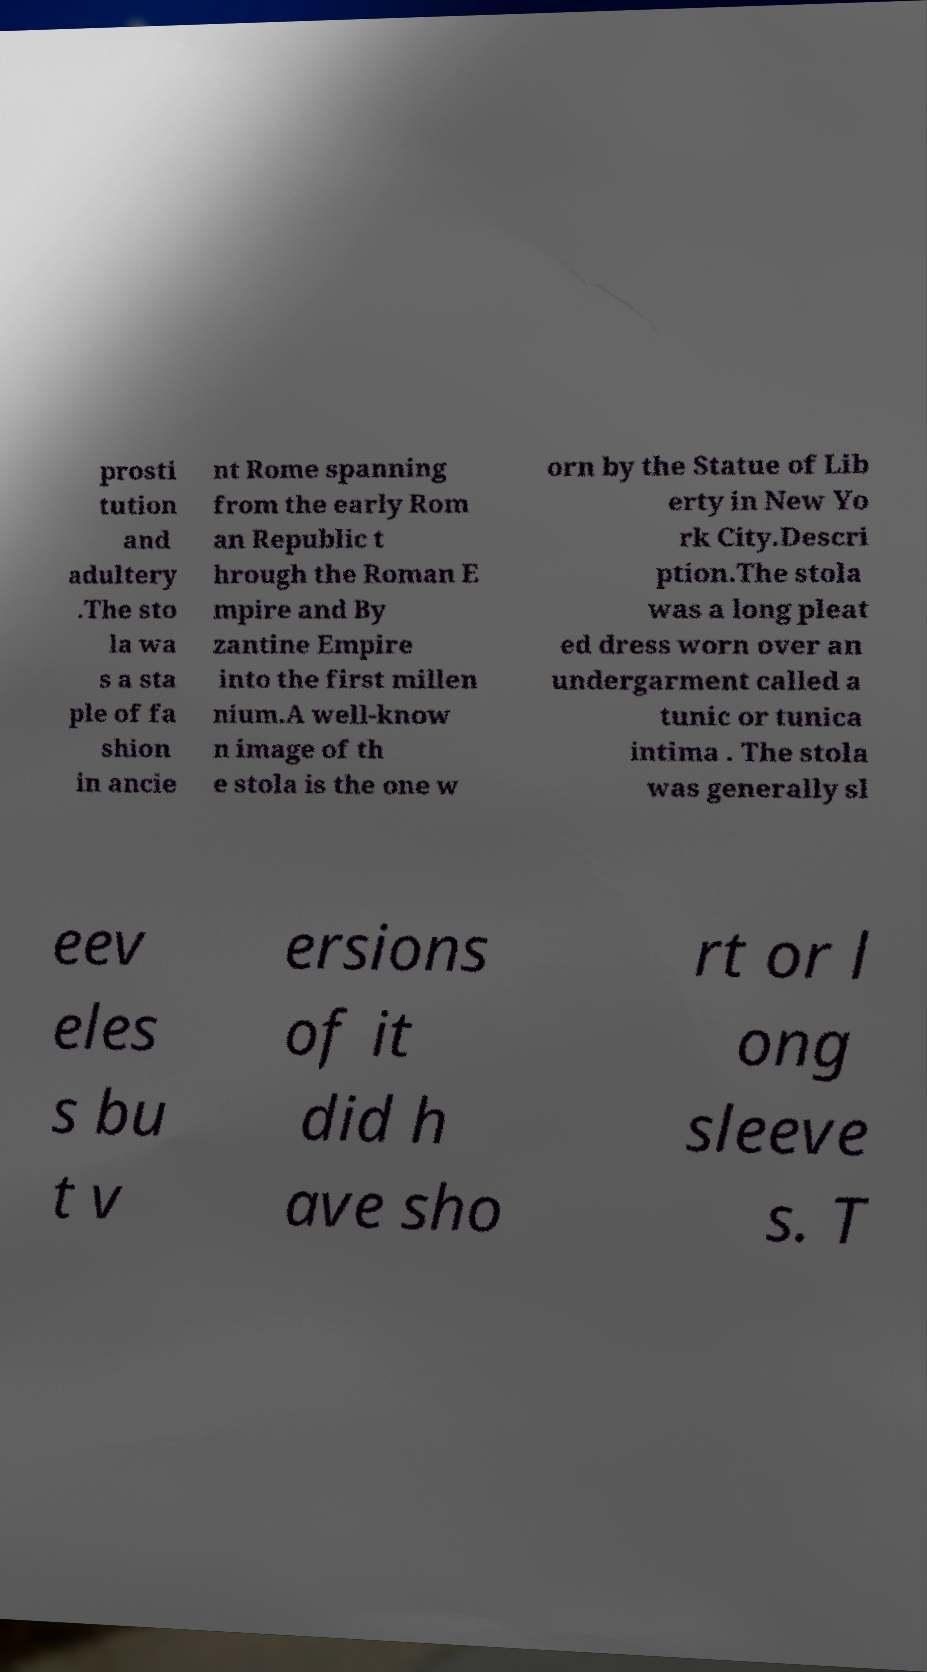Could you extract and type out the text from this image? prosti tution and adultery .The sto la wa s a sta ple of fa shion in ancie nt Rome spanning from the early Rom an Republic t hrough the Roman E mpire and By zantine Empire into the first millen nium.A well-know n image of th e stola is the one w orn by the Statue of Lib erty in New Yo rk City.Descri ption.The stola was a long pleat ed dress worn over an undergarment called a tunic or tunica intima . The stola was generally sl eev eles s bu t v ersions of it did h ave sho rt or l ong sleeve s. T 